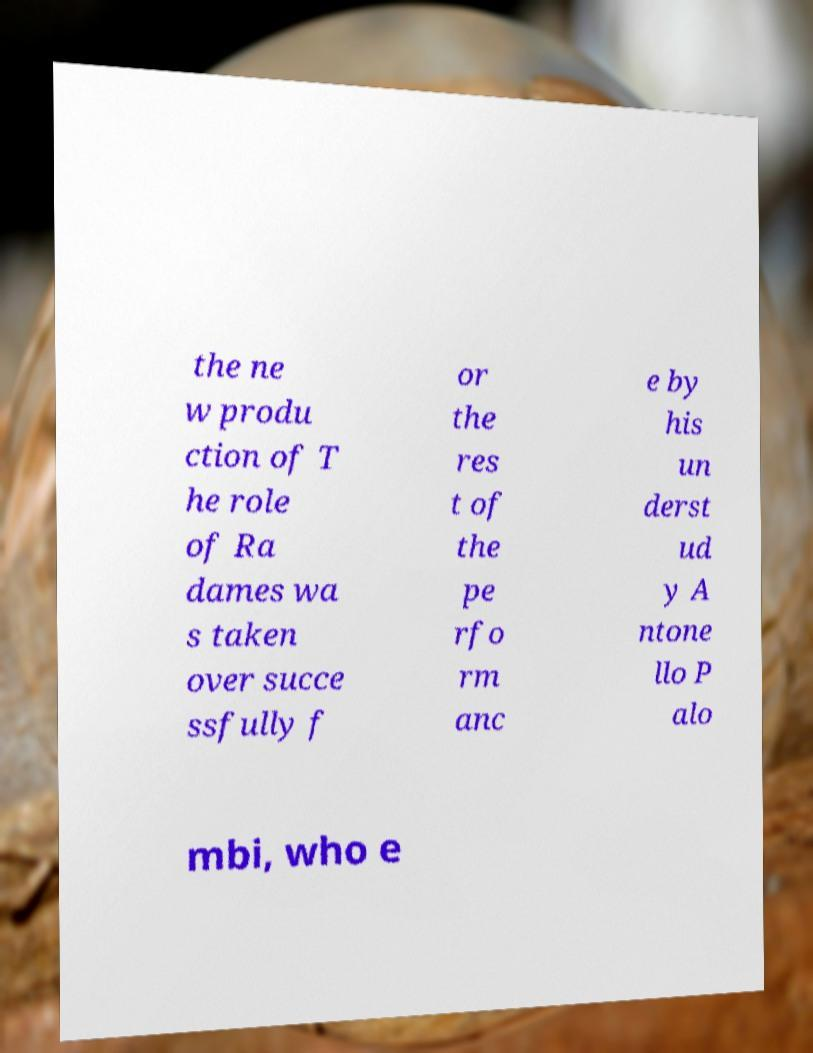Could you extract and type out the text from this image? the ne w produ ction of T he role of Ra dames wa s taken over succe ssfully f or the res t of the pe rfo rm anc e by his un derst ud y A ntone llo P alo mbi, who e 